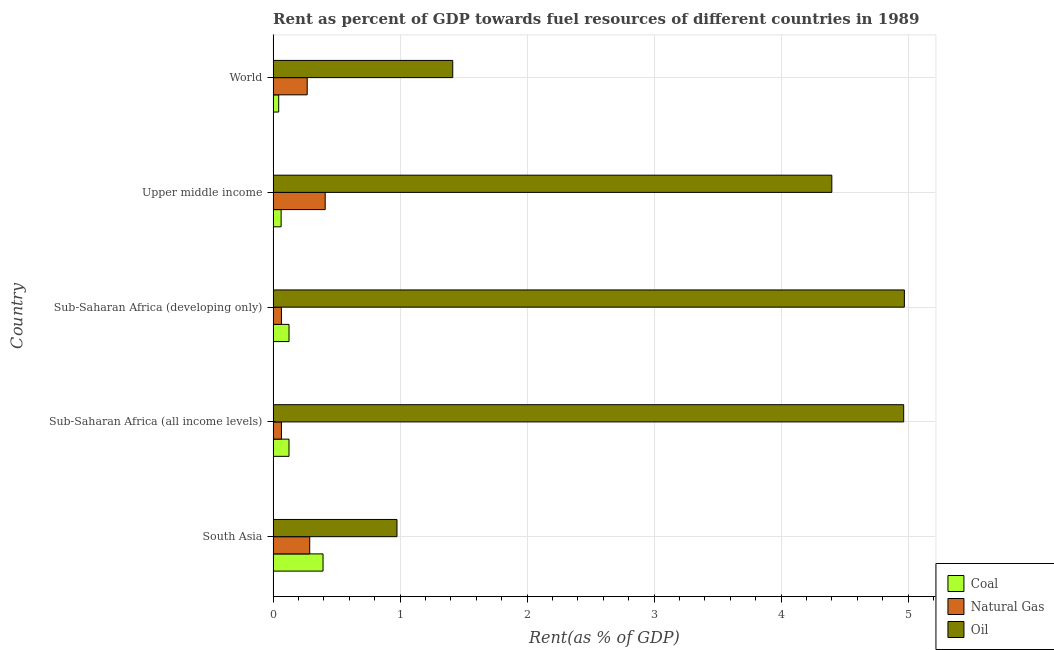How many different coloured bars are there?
Your answer should be compact. 3. How many groups of bars are there?
Provide a short and direct response. 5. Are the number of bars per tick equal to the number of legend labels?
Your answer should be compact. Yes. How many bars are there on the 1st tick from the top?
Offer a terse response. 3. What is the label of the 5th group of bars from the top?
Your response must be concise. South Asia. In how many cases, is the number of bars for a given country not equal to the number of legend labels?
Provide a succinct answer. 0. What is the rent towards coal in Sub-Saharan Africa (all income levels)?
Offer a terse response. 0.13. Across all countries, what is the maximum rent towards natural gas?
Provide a succinct answer. 0.41. Across all countries, what is the minimum rent towards oil?
Your response must be concise. 0.98. In which country was the rent towards oil maximum?
Make the answer very short. Sub-Saharan Africa (developing only). In which country was the rent towards coal minimum?
Provide a short and direct response. World. What is the total rent towards oil in the graph?
Ensure brevity in your answer.  16.73. What is the difference between the rent towards oil in South Asia and that in Upper middle income?
Provide a short and direct response. -3.42. What is the difference between the rent towards coal in South Asia and the rent towards oil in Sub-Saharan Africa (developing only)?
Your answer should be very brief. -4.58. What is the average rent towards coal per country?
Your answer should be very brief. 0.15. What is the difference between the rent towards natural gas and rent towards coal in Sub-Saharan Africa (all income levels)?
Ensure brevity in your answer.  -0.06. In how many countries, is the rent towards coal greater than 1.8 %?
Make the answer very short. 0. What is the ratio of the rent towards natural gas in South Asia to that in Sub-Saharan Africa (all income levels)?
Ensure brevity in your answer.  4.4. Is the rent towards oil in Sub-Saharan Africa (all income levels) less than that in Sub-Saharan Africa (developing only)?
Provide a short and direct response. Yes. What is the difference between the highest and the second highest rent towards natural gas?
Give a very brief answer. 0.12. What is the difference between the highest and the lowest rent towards natural gas?
Your answer should be very brief. 0.34. What does the 1st bar from the top in Sub-Saharan Africa (all income levels) represents?
Make the answer very short. Oil. What does the 2nd bar from the bottom in Sub-Saharan Africa (all income levels) represents?
Your answer should be compact. Natural Gas. How many countries are there in the graph?
Ensure brevity in your answer.  5. What is the difference between two consecutive major ticks on the X-axis?
Keep it short and to the point. 1. Does the graph contain any zero values?
Ensure brevity in your answer.  No. Where does the legend appear in the graph?
Ensure brevity in your answer.  Bottom right. How are the legend labels stacked?
Your response must be concise. Vertical. What is the title of the graph?
Offer a very short reply. Rent as percent of GDP towards fuel resources of different countries in 1989. Does "Slovak Republic" appear as one of the legend labels in the graph?
Your response must be concise. No. What is the label or title of the X-axis?
Keep it short and to the point. Rent(as % of GDP). What is the label or title of the Y-axis?
Make the answer very short. Country. What is the Rent(as % of GDP) in Coal in South Asia?
Provide a succinct answer. 0.39. What is the Rent(as % of GDP) in Natural Gas in South Asia?
Offer a terse response. 0.29. What is the Rent(as % of GDP) in Oil in South Asia?
Provide a short and direct response. 0.98. What is the Rent(as % of GDP) of Coal in Sub-Saharan Africa (all income levels)?
Offer a very short reply. 0.13. What is the Rent(as % of GDP) of Natural Gas in Sub-Saharan Africa (all income levels)?
Keep it short and to the point. 0.07. What is the Rent(as % of GDP) of Oil in Sub-Saharan Africa (all income levels)?
Your answer should be very brief. 4.97. What is the Rent(as % of GDP) of Coal in Sub-Saharan Africa (developing only)?
Provide a short and direct response. 0.13. What is the Rent(as % of GDP) of Natural Gas in Sub-Saharan Africa (developing only)?
Ensure brevity in your answer.  0.07. What is the Rent(as % of GDP) of Oil in Sub-Saharan Africa (developing only)?
Your response must be concise. 4.97. What is the Rent(as % of GDP) in Coal in Upper middle income?
Offer a terse response. 0.06. What is the Rent(as % of GDP) of Natural Gas in Upper middle income?
Your answer should be very brief. 0.41. What is the Rent(as % of GDP) of Oil in Upper middle income?
Make the answer very short. 4.4. What is the Rent(as % of GDP) of Coal in World?
Ensure brevity in your answer.  0.04. What is the Rent(as % of GDP) of Natural Gas in World?
Provide a succinct answer. 0.27. What is the Rent(as % of GDP) of Oil in World?
Give a very brief answer. 1.41. Across all countries, what is the maximum Rent(as % of GDP) of Coal?
Your response must be concise. 0.39. Across all countries, what is the maximum Rent(as % of GDP) of Natural Gas?
Your response must be concise. 0.41. Across all countries, what is the maximum Rent(as % of GDP) of Oil?
Provide a short and direct response. 4.97. Across all countries, what is the minimum Rent(as % of GDP) of Coal?
Keep it short and to the point. 0.04. Across all countries, what is the minimum Rent(as % of GDP) of Natural Gas?
Offer a terse response. 0.07. Across all countries, what is the minimum Rent(as % of GDP) in Oil?
Make the answer very short. 0.98. What is the total Rent(as % of GDP) in Coal in the graph?
Make the answer very short. 0.75. What is the total Rent(as % of GDP) of Natural Gas in the graph?
Your answer should be very brief. 1.1. What is the total Rent(as % of GDP) in Oil in the graph?
Keep it short and to the point. 16.73. What is the difference between the Rent(as % of GDP) of Coal in South Asia and that in Sub-Saharan Africa (all income levels)?
Offer a terse response. 0.27. What is the difference between the Rent(as % of GDP) of Natural Gas in South Asia and that in Sub-Saharan Africa (all income levels)?
Ensure brevity in your answer.  0.22. What is the difference between the Rent(as % of GDP) in Oil in South Asia and that in Sub-Saharan Africa (all income levels)?
Your answer should be compact. -3.99. What is the difference between the Rent(as % of GDP) of Coal in South Asia and that in Sub-Saharan Africa (developing only)?
Keep it short and to the point. 0.27. What is the difference between the Rent(as % of GDP) in Natural Gas in South Asia and that in Sub-Saharan Africa (developing only)?
Provide a succinct answer. 0.22. What is the difference between the Rent(as % of GDP) in Oil in South Asia and that in Sub-Saharan Africa (developing only)?
Provide a succinct answer. -4. What is the difference between the Rent(as % of GDP) of Coal in South Asia and that in Upper middle income?
Your answer should be very brief. 0.33. What is the difference between the Rent(as % of GDP) in Natural Gas in South Asia and that in Upper middle income?
Ensure brevity in your answer.  -0.12. What is the difference between the Rent(as % of GDP) of Oil in South Asia and that in Upper middle income?
Offer a very short reply. -3.42. What is the difference between the Rent(as % of GDP) of Coal in South Asia and that in World?
Ensure brevity in your answer.  0.35. What is the difference between the Rent(as % of GDP) in Natural Gas in South Asia and that in World?
Offer a very short reply. 0.02. What is the difference between the Rent(as % of GDP) in Oil in South Asia and that in World?
Keep it short and to the point. -0.44. What is the difference between the Rent(as % of GDP) of Coal in Sub-Saharan Africa (all income levels) and that in Sub-Saharan Africa (developing only)?
Your answer should be very brief. -0. What is the difference between the Rent(as % of GDP) of Natural Gas in Sub-Saharan Africa (all income levels) and that in Sub-Saharan Africa (developing only)?
Your answer should be compact. -0. What is the difference between the Rent(as % of GDP) of Oil in Sub-Saharan Africa (all income levels) and that in Sub-Saharan Africa (developing only)?
Your answer should be very brief. -0.01. What is the difference between the Rent(as % of GDP) in Coal in Sub-Saharan Africa (all income levels) and that in Upper middle income?
Offer a terse response. 0.06. What is the difference between the Rent(as % of GDP) in Natural Gas in Sub-Saharan Africa (all income levels) and that in Upper middle income?
Your answer should be very brief. -0.34. What is the difference between the Rent(as % of GDP) in Oil in Sub-Saharan Africa (all income levels) and that in Upper middle income?
Your answer should be very brief. 0.57. What is the difference between the Rent(as % of GDP) of Coal in Sub-Saharan Africa (all income levels) and that in World?
Provide a short and direct response. 0.08. What is the difference between the Rent(as % of GDP) of Natural Gas in Sub-Saharan Africa (all income levels) and that in World?
Keep it short and to the point. -0.2. What is the difference between the Rent(as % of GDP) in Oil in Sub-Saharan Africa (all income levels) and that in World?
Offer a very short reply. 3.55. What is the difference between the Rent(as % of GDP) in Coal in Sub-Saharan Africa (developing only) and that in Upper middle income?
Offer a very short reply. 0.06. What is the difference between the Rent(as % of GDP) in Natural Gas in Sub-Saharan Africa (developing only) and that in Upper middle income?
Offer a very short reply. -0.34. What is the difference between the Rent(as % of GDP) of Oil in Sub-Saharan Africa (developing only) and that in Upper middle income?
Offer a terse response. 0.57. What is the difference between the Rent(as % of GDP) in Coal in Sub-Saharan Africa (developing only) and that in World?
Your response must be concise. 0.08. What is the difference between the Rent(as % of GDP) in Natural Gas in Sub-Saharan Africa (developing only) and that in World?
Keep it short and to the point. -0.2. What is the difference between the Rent(as % of GDP) of Oil in Sub-Saharan Africa (developing only) and that in World?
Offer a very short reply. 3.56. What is the difference between the Rent(as % of GDP) in Coal in Upper middle income and that in World?
Keep it short and to the point. 0.02. What is the difference between the Rent(as % of GDP) in Natural Gas in Upper middle income and that in World?
Your response must be concise. 0.14. What is the difference between the Rent(as % of GDP) in Oil in Upper middle income and that in World?
Your answer should be very brief. 2.99. What is the difference between the Rent(as % of GDP) in Coal in South Asia and the Rent(as % of GDP) in Natural Gas in Sub-Saharan Africa (all income levels)?
Keep it short and to the point. 0.33. What is the difference between the Rent(as % of GDP) in Coal in South Asia and the Rent(as % of GDP) in Oil in Sub-Saharan Africa (all income levels)?
Your answer should be compact. -4.57. What is the difference between the Rent(as % of GDP) in Natural Gas in South Asia and the Rent(as % of GDP) in Oil in Sub-Saharan Africa (all income levels)?
Give a very brief answer. -4.68. What is the difference between the Rent(as % of GDP) in Coal in South Asia and the Rent(as % of GDP) in Natural Gas in Sub-Saharan Africa (developing only)?
Offer a very short reply. 0.33. What is the difference between the Rent(as % of GDP) in Coal in South Asia and the Rent(as % of GDP) in Oil in Sub-Saharan Africa (developing only)?
Keep it short and to the point. -4.58. What is the difference between the Rent(as % of GDP) of Natural Gas in South Asia and the Rent(as % of GDP) of Oil in Sub-Saharan Africa (developing only)?
Give a very brief answer. -4.68. What is the difference between the Rent(as % of GDP) of Coal in South Asia and the Rent(as % of GDP) of Natural Gas in Upper middle income?
Keep it short and to the point. -0.02. What is the difference between the Rent(as % of GDP) in Coal in South Asia and the Rent(as % of GDP) in Oil in Upper middle income?
Ensure brevity in your answer.  -4.01. What is the difference between the Rent(as % of GDP) of Natural Gas in South Asia and the Rent(as % of GDP) of Oil in Upper middle income?
Provide a short and direct response. -4.11. What is the difference between the Rent(as % of GDP) of Coal in South Asia and the Rent(as % of GDP) of Natural Gas in World?
Offer a terse response. 0.12. What is the difference between the Rent(as % of GDP) of Coal in South Asia and the Rent(as % of GDP) of Oil in World?
Make the answer very short. -1.02. What is the difference between the Rent(as % of GDP) of Natural Gas in South Asia and the Rent(as % of GDP) of Oil in World?
Make the answer very short. -1.13. What is the difference between the Rent(as % of GDP) in Coal in Sub-Saharan Africa (all income levels) and the Rent(as % of GDP) in Natural Gas in Sub-Saharan Africa (developing only)?
Provide a succinct answer. 0.06. What is the difference between the Rent(as % of GDP) in Coal in Sub-Saharan Africa (all income levels) and the Rent(as % of GDP) in Oil in Sub-Saharan Africa (developing only)?
Your response must be concise. -4.85. What is the difference between the Rent(as % of GDP) in Natural Gas in Sub-Saharan Africa (all income levels) and the Rent(as % of GDP) in Oil in Sub-Saharan Africa (developing only)?
Provide a succinct answer. -4.91. What is the difference between the Rent(as % of GDP) in Coal in Sub-Saharan Africa (all income levels) and the Rent(as % of GDP) in Natural Gas in Upper middle income?
Provide a short and direct response. -0.28. What is the difference between the Rent(as % of GDP) of Coal in Sub-Saharan Africa (all income levels) and the Rent(as % of GDP) of Oil in Upper middle income?
Provide a succinct answer. -4.27. What is the difference between the Rent(as % of GDP) in Natural Gas in Sub-Saharan Africa (all income levels) and the Rent(as % of GDP) in Oil in Upper middle income?
Your response must be concise. -4.33. What is the difference between the Rent(as % of GDP) of Coal in Sub-Saharan Africa (all income levels) and the Rent(as % of GDP) of Natural Gas in World?
Your response must be concise. -0.14. What is the difference between the Rent(as % of GDP) in Coal in Sub-Saharan Africa (all income levels) and the Rent(as % of GDP) in Oil in World?
Your response must be concise. -1.29. What is the difference between the Rent(as % of GDP) in Natural Gas in Sub-Saharan Africa (all income levels) and the Rent(as % of GDP) in Oil in World?
Keep it short and to the point. -1.35. What is the difference between the Rent(as % of GDP) of Coal in Sub-Saharan Africa (developing only) and the Rent(as % of GDP) of Natural Gas in Upper middle income?
Ensure brevity in your answer.  -0.28. What is the difference between the Rent(as % of GDP) of Coal in Sub-Saharan Africa (developing only) and the Rent(as % of GDP) of Oil in Upper middle income?
Offer a terse response. -4.27. What is the difference between the Rent(as % of GDP) of Natural Gas in Sub-Saharan Africa (developing only) and the Rent(as % of GDP) of Oil in Upper middle income?
Ensure brevity in your answer.  -4.33. What is the difference between the Rent(as % of GDP) in Coal in Sub-Saharan Africa (developing only) and the Rent(as % of GDP) in Natural Gas in World?
Make the answer very short. -0.14. What is the difference between the Rent(as % of GDP) of Coal in Sub-Saharan Africa (developing only) and the Rent(as % of GDP) of Oil in World?
Offer a terse response. -1.29. What is the difference between the Rent(as % of GDP) of Natural Gas in Sub-Saharan Africa (developing only) and the Rent(as % of GDP) of Oil in World?
Keep it short and to the point. -1.35. What is the difference between the Rent(as % of GDP) of Coal in Upper middle income and the Rent(as % of GDP) of Natural Gas in World?
Offer a terse response. -0.21. What is the difference between the Rent(as % of GDP) in Coal in Upper middle income and the Rent(as % of GDP) in Oil in World?
Your response must be concise. -1.35. What is the difference between the Rent(as % of GDP) of Natural Gas in Upper middle income and the Rent(as % of GDP) of Oil in World?
Your answer should be very brief. -1. What is the average Rent(as % of GDP) in Coal per country?
Provide a succinct answer. 0.15. What is the average Rent(as % of GDP) in Natural Gas per country?
Your response must be concise. 0.22. What is the average Rent(as % of GDP) of Oil per country?
Make the answer very short. 3.35. What is the difference between the Rent(as % of GDP) in Coal and Rent(as % of GDP) in Natural Gas in South Asia?
Your response must be concise. 0.1. What is the difference between the Rent(as % of GDP) of Coal and Rent(as % of GDP) of Oil in South Asia?
Make the answer very short. -0.58. What is the difference between the Rent(as % of GDP) of Natural Gas and Rent(as % of GDP) of Oil in South Asia?
Keep it short and to the point. -0.69. What is the difference between the Rent(as % of GDP) of Coal and Rent(as % of GDP) of Natural Gas in Sub-Saharan Africa (all income levels)?
Your answer should be very brief. 0.06. What is the difference between the Rent(as % of GDP) in Coal and Rent(as % of GDP) in Oil in Sub-Saharan Africa (all income levels)?
Ensure brevity in your answer.  -4.84. What is the difference between the Rent(as % of GDP) in Natural Gas and Rent(as % of GDP) in Oil in Sub-Saharan Africa (all income levels)?
Ensure brevity in your answer.  -4.9. What is the difference between the Rent(as % of GDP) of Coal and Rent(as % of GDP) of Natural Gas in Sub-Saharan Africa (developing only)?
Your response must be concise. 0.06. What is the difference between the Rent(as % of GDP) in Coal and Rent(as % of GDP) in Oil in Sub-Saharan Africa (developing only)?
Your answer should be very brief. -4.85. What is the difference between the Rent(as % of GDP) in Natural Gas and Rent(as % of GDP) in Oil in Sub-Saharan Africa (developing only)?
Keep it short and to the point. -4.91. What is the difference between the Rent(as % of GDP) in Coal and Rent(as % of GDP) in Natural Gas in Upper middle income?
Your answer should be very brief. -0.35. What is the difference between the Rent(as % of GDP) in Coal and Rent(as % of GDP) in Oil in Upper middle income?
Provide a short and direct response. -4.34. What is the difference between the Rent(as % of GDP) of Natural Gas and Rent(as % of GDP) of Oil in Upper middle income?
Provide a succinct answer. -3.99. What is the difference between the Rent(as % of GDP) of Coal and Rent(as % of GDP) of Natural Gas in World?
Provide a short and direct response. -0.22. What is the difference between the Rent(as % of GDP) in Coal and Rent(as % of GDP) in Oil in World?
Make the answer very short. -1.37. What is the difference between the Rent(as % of GDP) of Natural Gas and Rent(as % of GDP) of Oil in World?
Offer a terse response. -1.15. What is the ratio of the Rent(as % of GDP) in Coal in South Asia to that in Sub-Saharan Africa (all income levels)?
Your answer should be compact. 3.14. What is the ratio of the Rent(as % of GDP) in Natural Gas in South Asia to that in Sub-Saharan Africa (all income levels)?
Your response must be concise. 4.4. What is the ratio of the Rent(as % of GDP) in Oil in South Asia to that in Sub-Saharan Africa (all income levels)?
Provide a short and direct response. 0.2. What is the ratio of the Rent(as % of GDP) of Coal in South Asia to that in Sub-Saharan Africa (developing only)?
Provide a short and direct response. 3.14. What is the ratio of the Rent(as % of GDP) of Natural Gas in South Asia to that in Sub-Saharan Africa (developing only)?
Offer a very short reply. 4.4. What is the ratio of the Rent(as % of GDP) in Oil in South Asia to that in Sub-Saharan Africa (developing only)?
Your answer should be very brief. 0.2. What is the ratio of the Rent(as % of GDP) of Coal in South Asia to that in Upper middle income?
Provide a short and direct response. 6.24. What is the ratio of the Rent(as % of GDP) in Natural Gas in South Asia to that in Upper middle income?
Provide a succinct answer. 0.7. What is the ratio of the Rent(as % of GDP) in Oil in South Asia to that in Upper middle income?
Ensure brevity in your answer.  0.22. What is the ratio of the Rent(as % of GDP) in Coal in South Asia to that in World?
Give a very brief answer. 8.94. What is the ratio of the Rent(as % of GDP) in Natural Gas in South Asia to that in World?
Your answer should be compact. 1.07. What is the ratio of the Rent(as % of GDP) in Oil in South Asia to that in World?
Provide a short and direct response. 0.69. What is the ratio of the Rent(as % of GDP) of Coal in Sub-Saharan Africa (all income levels) to that in Sub-Saharan Africa (developing only)?
Ensure brevity in your answer.  1. What is the ratio of the Rent(as % of GDP) of Coal in Sub-Saharan Africa (all income levels) to that in Upper middle income?
Offer a very short reply. 1.98. What is the ratio of the Rent(as % of GDP) in Natural Gas in Sub-Saharan Africa (all income levels) to that in Upper middle income?
Make the answer very short. 0.16. What is the ratio of the Rent(as % of GDP) in Oil in Sub-Saharan Africa (all income levels) to that in Upper middle income?
Provide a short and direct response. 1.13. What is the ratio of the Rent(as % of GDP) in Coal in Sub-Saharan Africa (all income levels) to that in World?
Provide a short and direct response. 2.84. What is the ratio of the Rent(as % of GDP) of Natural Gas in Sub-Saharan Africa (all income levels) to that in World?
Your answer should be very brief. 0.24. What is the ratio of the Rent(as % of GDP) in Oil in Sub-Saharan Africa (all income levels) to that in World?
Provide a succinct answer. 3.51. What is the ratio of the Rent(as % of GDP) of Coal in Sub-Saharan Africa (developing only) to that in Upper middle income?
Your answer should be compact. 1.99. What is the ratio of the Rent(as % of GDP) of Natural Gas in Sub-Saharan Africa (developing only) to that in Upper middle income?
Make the answer very short. 0.16. What is the ratio of the Rent(as % of GDP) in Oil in Sub-Saharan Africa (developing only) to that in Upper middle income?
Your response must be concise. 1.13. What is the ratio of the Rent(as % of GDP) of Coal in Sub-Saharan Africa (developing only) to that in World?
Offer a terse response. 2.85. What is the ratio of the Rent(as % of GDP) in Natural Gas in Sub-Saharan Africa (developing only) to that in World?
Keep it short and to the point. 0.24. What is the ratio of the Rent(as % of GDP) in Oil in Sub-Saharan Africa (developing only) to that in World?
Make the answer very short. 3.51. What is the ratio of the Rent(as % of GDP) in Coal in Upper middle income to that in World?
Offer a very short reply. 1.43. What is the ratio of the Rent(as % of GDP) of Natural Gas in Upper middle income to that in World?
Provide a short and direct response. 1.53. What is the ratio of the Rent(as % of GDP) in Oil in Upper middle income to that in World?
Give a very brief answer. 3.11. What is the difference between the highest and the second highest Rent(as % of GDP) in Coal?
Offer a very short reply. 0.27. What is the difference between the highest and the second highest Rent(as % of GDP) of Natural Gas?
Offer a very short reply. 0.12. What is the difference between the highest and the second highest Rent(as % of GDP) in Oil?
Offer a very short reply. 0.01. What is the difference between the highest and the lowest Rent(as % of GDP) of Coal?
Make the answer very short. 0.35. What is the difference between the highest and the lowest Rent(as % of GDP) of Natural Gas?
Keep it short and to the point. 0.34. What is the difference between the highest and the lowest Rent(as % of GDP) of Oil?
Your response must be concise. 4. 